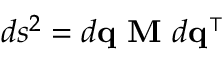Convert formula to latex. <formula><loc_0><loc_0><loc_500><loc_500>d s ^ { 2 } = d q \ M \ d q ^ { \intercal }</formula> 